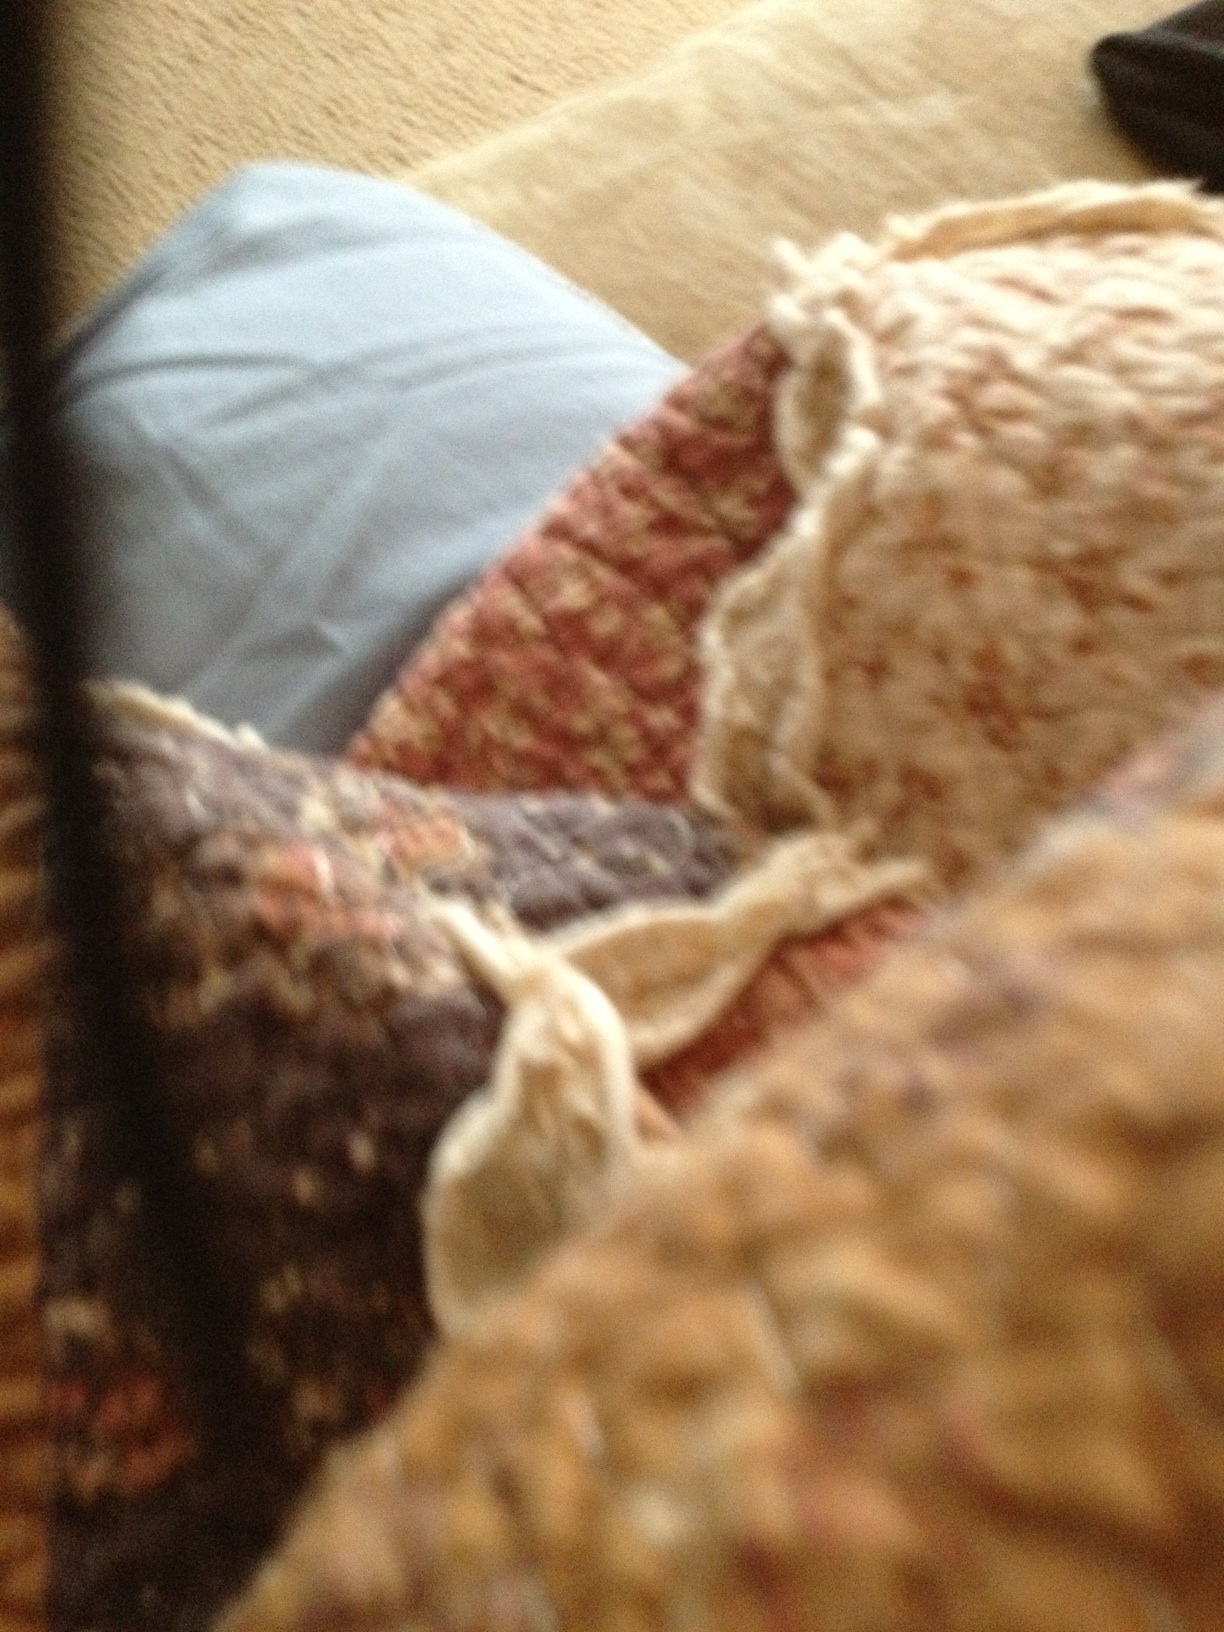Can you describe the texture of the material in the image? The material appears to have a rich, woven texture, featuring a mix of rough and smooth surfaces. The weaves are created with threads in different colors, namely burgundy red, cream, and blue, coming together to form a cozy and rustic fabric. Is this material suitable for a cozy winter blanket? Absolutely! The fabric in the image seems ideal for a cozy winter blanket. The dense weaving and the combination of warm colors like burgundy red and cream would provide both warmth and a sense of comfort, making it perfect for snuggling up on a cold evening. Imagine if this blanket could speak. What kind of story do you think it would tell? If this blanket could speak, it might tell the story of being carefully handcrafted by a loving artisan, who chose each thread with care. It might recall the many cozy nights it has spent wrapped around its owner while they read books, watched movies, or simply drifted off to sleep. It could share memories of being taken on picnics, used to build forts, and perhaps even wrapped around family pets. Each frayed edge and faded thread would be a testament to its journey and the comfort it has provided to its owners over the years. Describe a realistic scenario where this blanket becomes a cherished family heirloom. In a realistic scenario, this blanket becomes a cherished family heirloom as it gets passed down through generations. It starts with a grandmother who handmade it for her first grandchild. The child grows up with the blanket, bringing it along on family trips and cuddling with it during bedtime stories. As the years go by, the blanket sees many life events – first days of school, holidays, and even comfort during tough times. Eventually, that child becomes a parent and passes the blanket on to their own child, telling stories of how it was made and the memories associated with it. The blanket symbolizes continuity, love, and the warmth of family tradition. What if this blanket had magic powers? How would it use them? If this blanket had magic powers, it might be enchanted to provide the perfect amount of warmth, adjusting to the user's needs to ensure they are always comfortable. Perhaps it could cradle the dreams of those wrapped in it, bringing them peaceful and comforting visions at night. With a touch of magic, the blanket could also repair itself, mending any wear and tear to ensure it always stays in pristine condition. Additionally, the blanket might have the ability to tell stories to those snuggled beneath it, whispering tales of far-off lands and magical creatures, igniting the imagination and wonder of anyone who listens. 